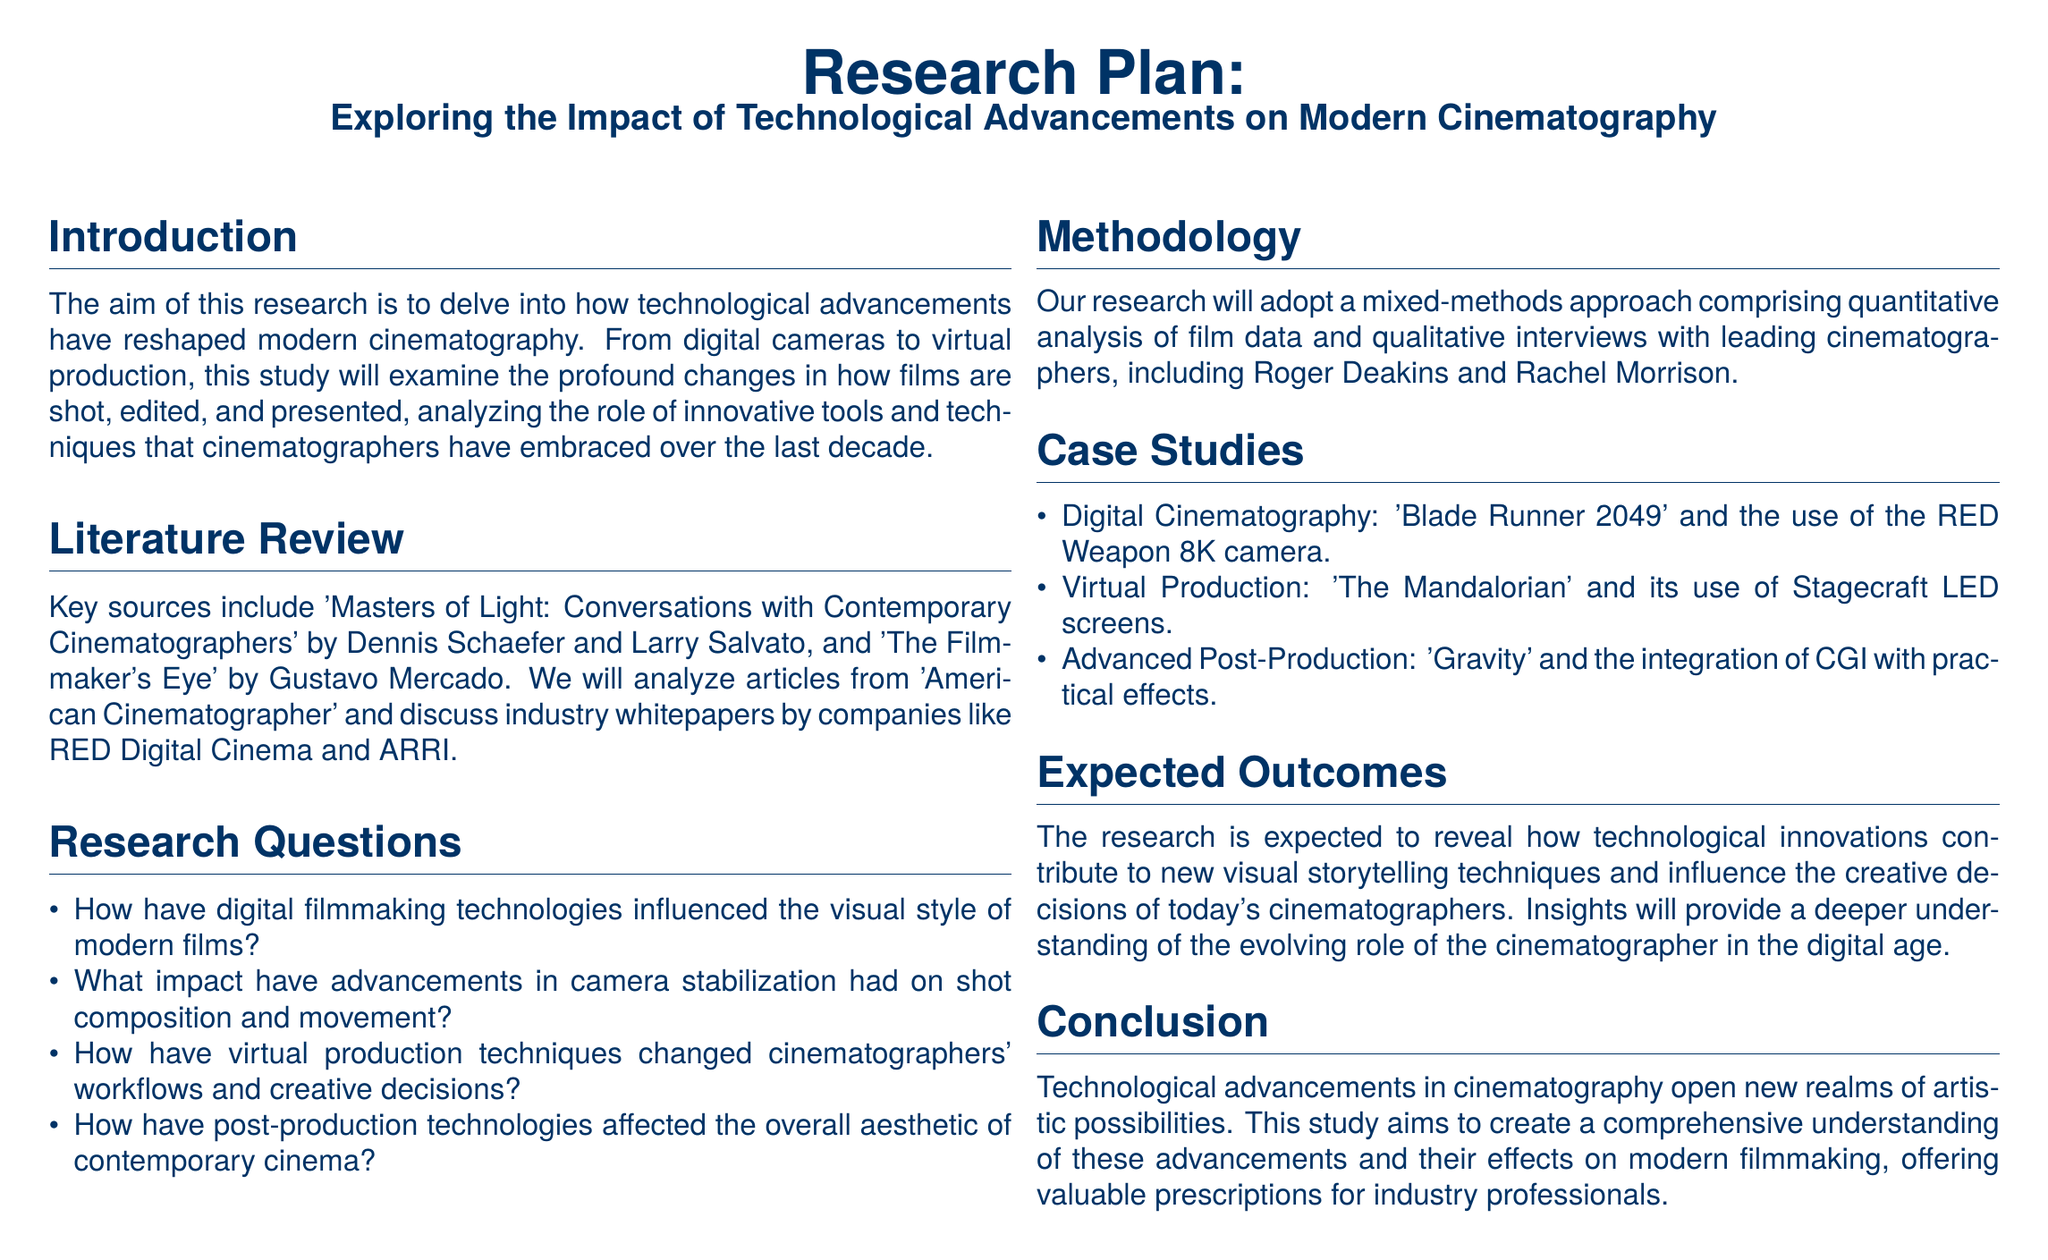What is the title of the research plan? The title is explicitly stated at the beginning of the document as "Exploring the Impact of Technological Advancements on Modern Cinematography."
Answer: Exploring the Impact of Technological Advancements on Modern Cinematography Who are the authors of "Masters of Light"? The document lists the authors as Dennis Schaefer and Larry Salvato.
Answer: Dennis Schaefer and Larry Salvato What is one of the case studies mentioned in the research plan? The case studies section specifically mentions "Blade Runner 2049."
Answer: Blade Runner 2049 How many research questions are listed in the document? The research questions are itemized in the research questions section, and there are four questions provided.
Answer: Four What methodology will be used for the research? The methodology section describes a "mixed-methods approach."
Answer: Mixed-methods approach What is an expected outcome of the research? The expected outcomes section indicates that the research aims to reveal how technological innovations contribute to new visual storytelling techniques.
Answer: New visual storytelling techniques What type of approach does the research incorporate? The methodology explains that the research will adopt a mixed-methods approach.
Answer: Mixed-methods What film is used as a case study for virtual production? The document mentions "The Mandalorian" as the specific film in the virtual production case study.
Answer: The Mandalorian 